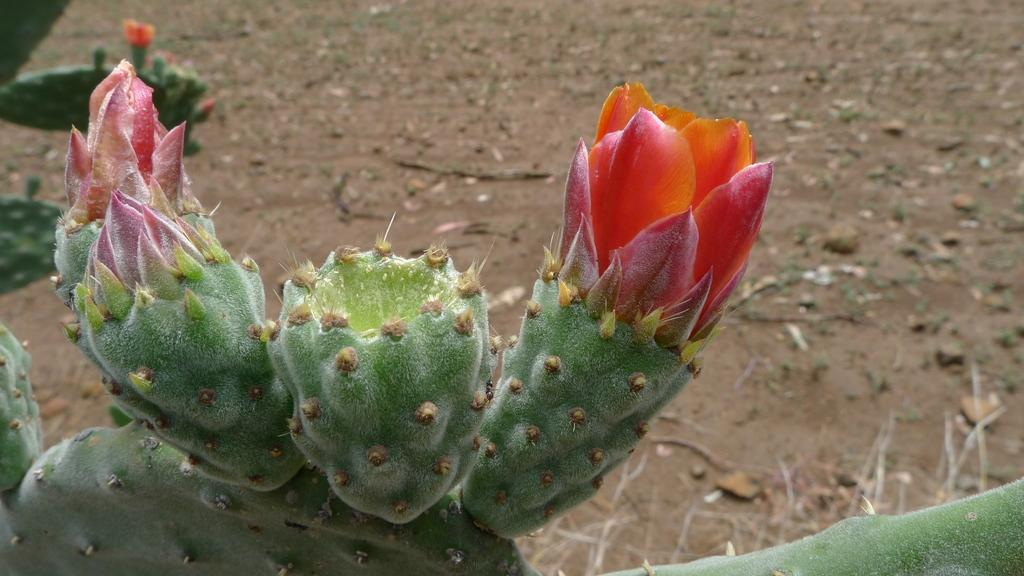What is located at the bottom of the image? There are plants at the bottom of the image. What type of surface is visible behind the plants? There is sand visible behind the plants. What type of rat can be seen holding a cup in the image? There is no rat or cup present in the image. What mark or symbol can be seen on the plants in the image? There is no mark or symbol visible on the plants in the image. 